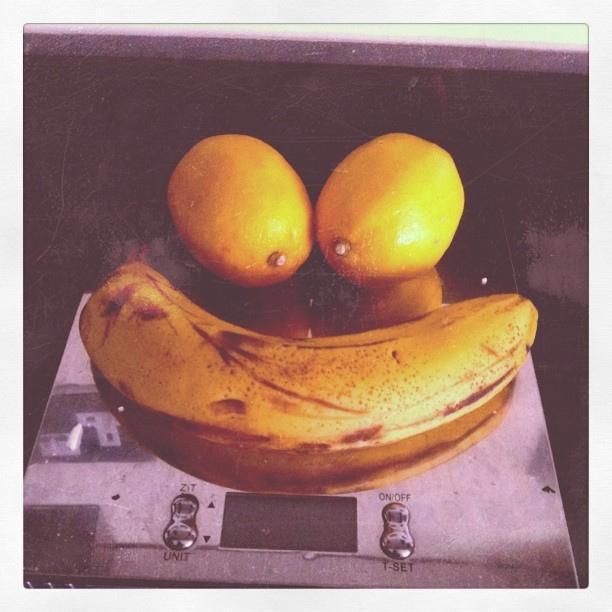How many bananas are in this picture?
Give a very brief answer. 1. How many oranges are in the picture?
Give a very brief answer. 2. 